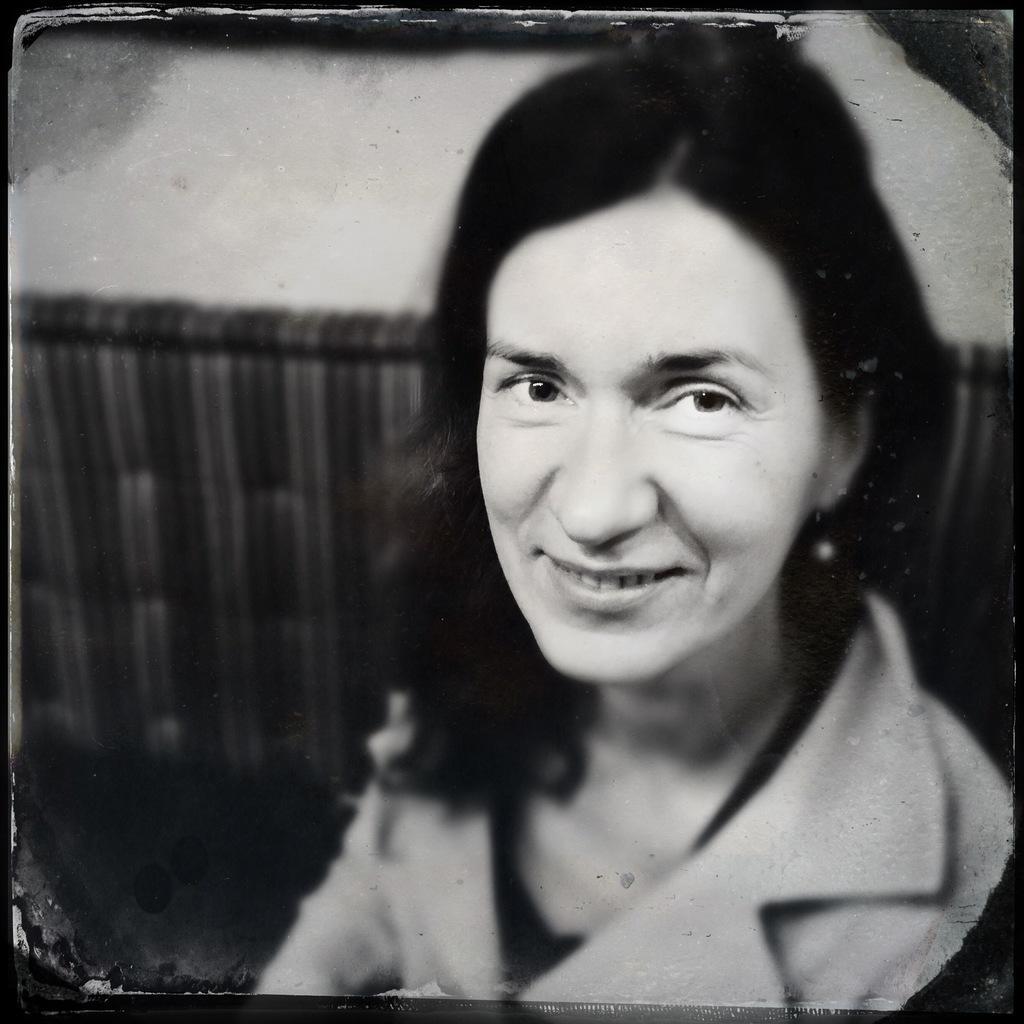In one or two sentences, can you explain what this image depicts? In this image we can see a black and white image of a woman. 